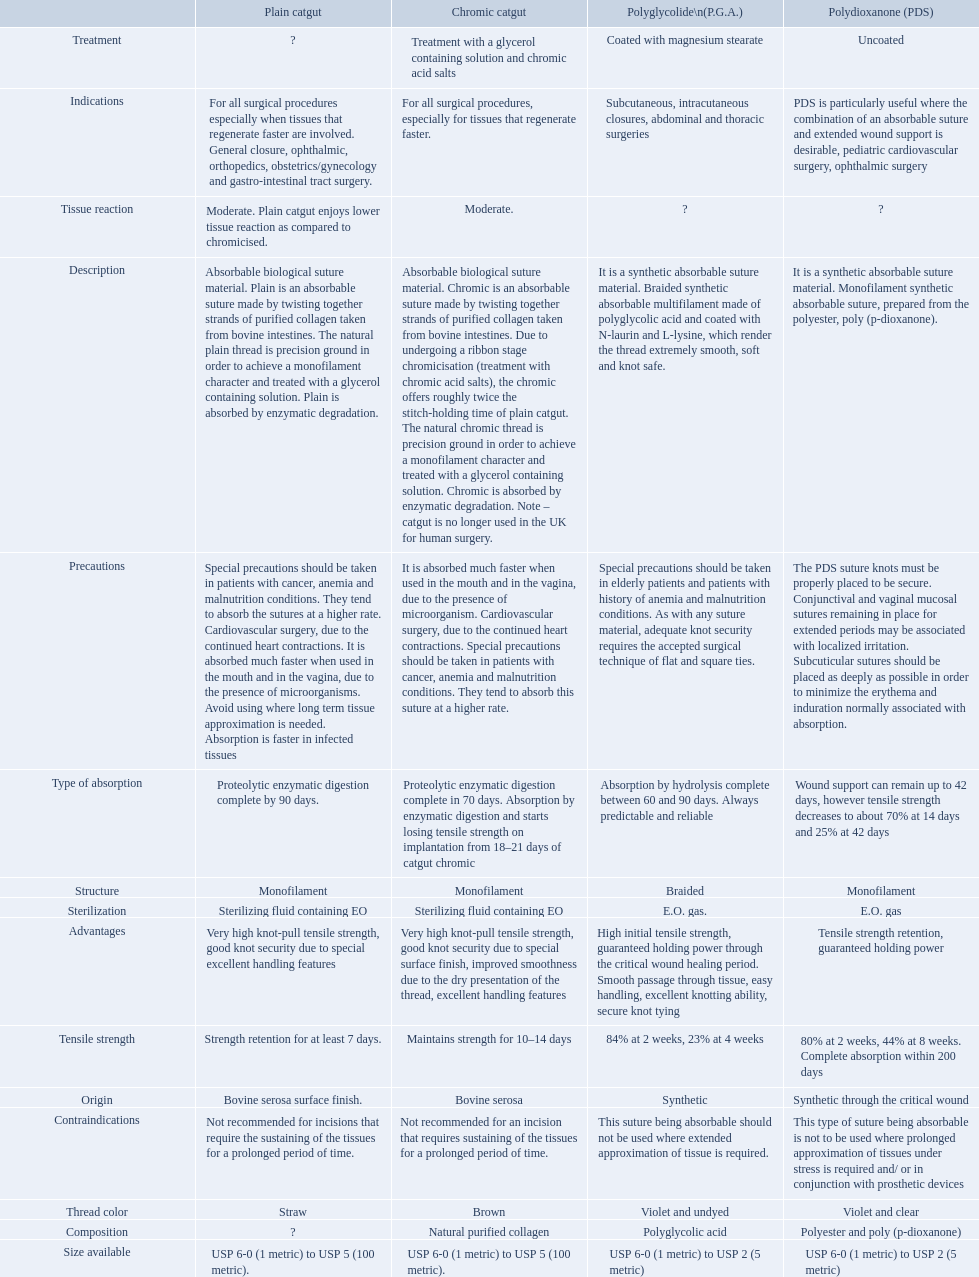Write the full table. {'header': ['', 'Plain catgut', 'Chromic catgut', 'Polyglycolide\\n(P.G.A.)', 'Polydioxanone (PDS)'], 'rows': [['Treatment', '?', 'Treatment with a glycerol containing solution and chromic acid salts', 'Coated with magnesium stearate', 'Uncoated'], ['Indications', 'For all surgical procedures especially when tissues that regenerate faster are involved. General closure, ophthalmic, orthopedics, obstetrics/gynecology and gastro-intestinal tract surgery.', 'For all surgical procedures, especially for tissues that regenerate faster.', 'Subcutaneous, intracutaneous closures, abdominal and thoracic surgeries', 'PDS is particularly useful where the combination of an absorbable suture and extended wound support is desirable, pediatric cardiovascular surgery, ophthalmic surgery'], ['Tissue reaction', 'Moderate. Plain catgut enjoys lower tissue reaction as compared to chromicised.', 'Moderate.', '?', '?'], ['Description', 'Absorbable biological suture material. Plain is an absorbable suture made by twisting together strands of purified collagen taken from bovine intestines. The natural plain thread is precision ground in order to achieve a monofilament character and treated with a glycerol containing solution. Plain is absorbed by enzymatic degradation.', 'Absorbable biological suture material. Chromic is an absorbable suture made by twisting together strands of purified collagen taken from bovine intestines. Due to undergoing a ribbon stage chromicisation (treatment with chromic acid salts), the chromic offers roughly twice the stitch-holding time of plain catgut. The natural chromic thread is precision ground in order to achieve a monofilament character and treated with a glycerol containing solution. Chromic is absorbed by enzymatic degradation. Note – catgut is no longer used in the UK for human surgery.', 'It is a synthetic absorbable suture material. Braided synthetic absorbable multifilament made of polyglycolic acid and coated with N-laurin and L-lysine, which render the thread extremely smooth, soft and knot safe.', 'It is a synthetic absorbable suture material. Monofilament synthetic absorbable suture, prepared from the polyester, poly (p-dioxanone).'], ['Precautions', 'Special precautions should be taken in patients with cancer, anemia and malnutrition conditions. They tend to absorb the sutures at a higher rate. Cardiovascular surgery, due to the continued heart contractions. It is absorbed much faster when used in the mouth and in the vagina, due to the presence of microorganisms. Avoid using where long term tissue approximation is needed. Absorption is faster in infected tissues', 'It is absorbed much faster when used in the mouth and in the vagina, due to the presence of microorganism. Cardiovascular surgery, due to the continued heart contractions. Special precautions should be taken in patients with cancer, anemia and malnutrition conditions. They tend to absorb this suture at a higher rate.', 'Special precautions should be taken in elderly patients and patients with history of anemia and malnutrition conditions. As with any suture material, adequate knot security requires the accepted surgical technique of flat and square ties.', 'The PDS suture knots must be properly placed to be secure. Conjunctival and vaginal mucosal sutures remaining in place for extended periods may be associated with localized irritation. Subcuticular sutures should be placed as deeply as possible in order to minimize the erythema and induration normally associated with absorption.'], ['Type of absorption', 'Proteolytic enzymatic digestion complete by 90 days.', 'Proteolytic enzymatic digestion complete in 70 days. Absorption by enzymatic digestion and starts losing tensile strength on implantation from 18–21 days of catgut chromic', 'Absorption by hydrolysis complete between 60 and 90 days. Always predictable and reliable', 'Wound support can remain up to 42 days, however tensile strength decreases to about 70% at 14 days and 25% at 42 days'], ['Structure', 'Monofilament', 'Monofilament', 'Braided', 'Monofilament'], ['Sterilization', 'Sterilizing fluid containing EO', 'Sterilizing fluid containing EO', 'E.O. gas.', 'E.O. gas'], ['Advantages', 'Very high knot-pull tensile strength, good knot security due to special excellent handling features', 'Very high knot-pull tensile strength, good knot security due to special surface finish, improved smoothness due to the dry presentation of the thread, excellent handling features', 'High initial tensile strength, guaranteed holding power through the critical wound healing period. Smooth passage through tissue, easy handling, excellent knotting ability, secure knot tying', 'Tensile strength retention, guaranteed holding power'], ['Tensile strength', 'Strength retention for at least 7 days.', 'Maintains strength for 10–14 days', '84% at 2 weeks, 23% at 4 weeks', '80% at 2 weeks, 44% at 8 weeks. Complete absorption within 200 days'], ['Origin', 'Bovine serosa surface finish.', 'Bovine serosa', 'Synthetic', 'Synthetic through the critical wound'], ['Contraindications', 'Not recommended for incisions that require the sustaining of the tissues for a prolonged period of time.', 'Not recommended for an incision that requires sustaining of the tissues for a prolonged period of time.', 'This suture being absorbable should not be used where extended approximation of tissue is required.', 'This type of suture being absorbable is not to be used where prolonged approximation of tissues under stress is required and/ or in conjunction with prosthetic devices'], ['Thread color', 'Straw', 'Brown', 'Violet and undyed', 'Violet and clear'], ['Composition', '?', 'Natural purified collagen', 'Polyglycolic acid', 'Polyester and poly (p-dioxanone)'], ['Size available', 'USP 6-0 (1 metric) to USP 5 (100 metric).', 'USP 6-0 (1 metric) to USP 5 (100 metric).', 'USP 6-0 (1 metric) to USP 2 (5 metric)', 'USP 6-0 (1 metric) to USP 2 (5 metric)']]} What categories are listed in the suture materials comparison chart? Description, Composition, Tensile strength, Structure, Origin, Treatment, Type of absorption, Tissue reaction, Thread color, Size available, Sterilization, Advantages, Indications, Contraindications, Precautions. Of the testile strength, which is the lowest? Strength retention for at least 7 days. 